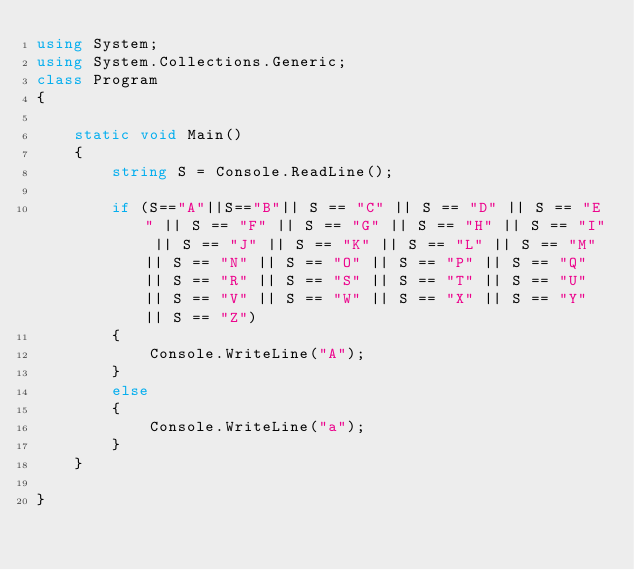<code> <loc_0><loc_0><loc_500><loc_500><_C#_>using System;
using System.Collections.Generic;
class Program
{

    static void Main()
    {
        string S = Console.ReadLine();

        if (S=="A"||S=="B"|| S == "C" || S == "D" || S == "E" || S == "F" || S == "G" || S == "H" || S == "I" || S == "J" || S == "K" || S == "L" || S == "M" || S == "N" || S == "O" || S == "P" || S == "Q" || S == "R" || S == "S" || S == "T" || S == "U" || S == "V" || S == "W" || S == "X" || S == "Y" || S == "Z")
        {
            Console.WriteLine("A");
        }
        else
        {
            Console.WriteLine("a");
        }
    }

}</code> 